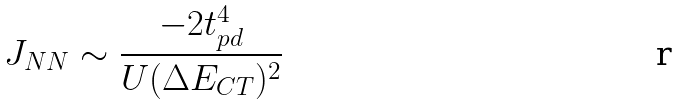<formula> <loc_0><loc_0><loc_500><loc_500>J _ { N N } \sim \frac { - 2 t _ { p d } ^ { 4 } } { U ( \Delta E _ { C T } ) ^ { 2 } }</formula> 